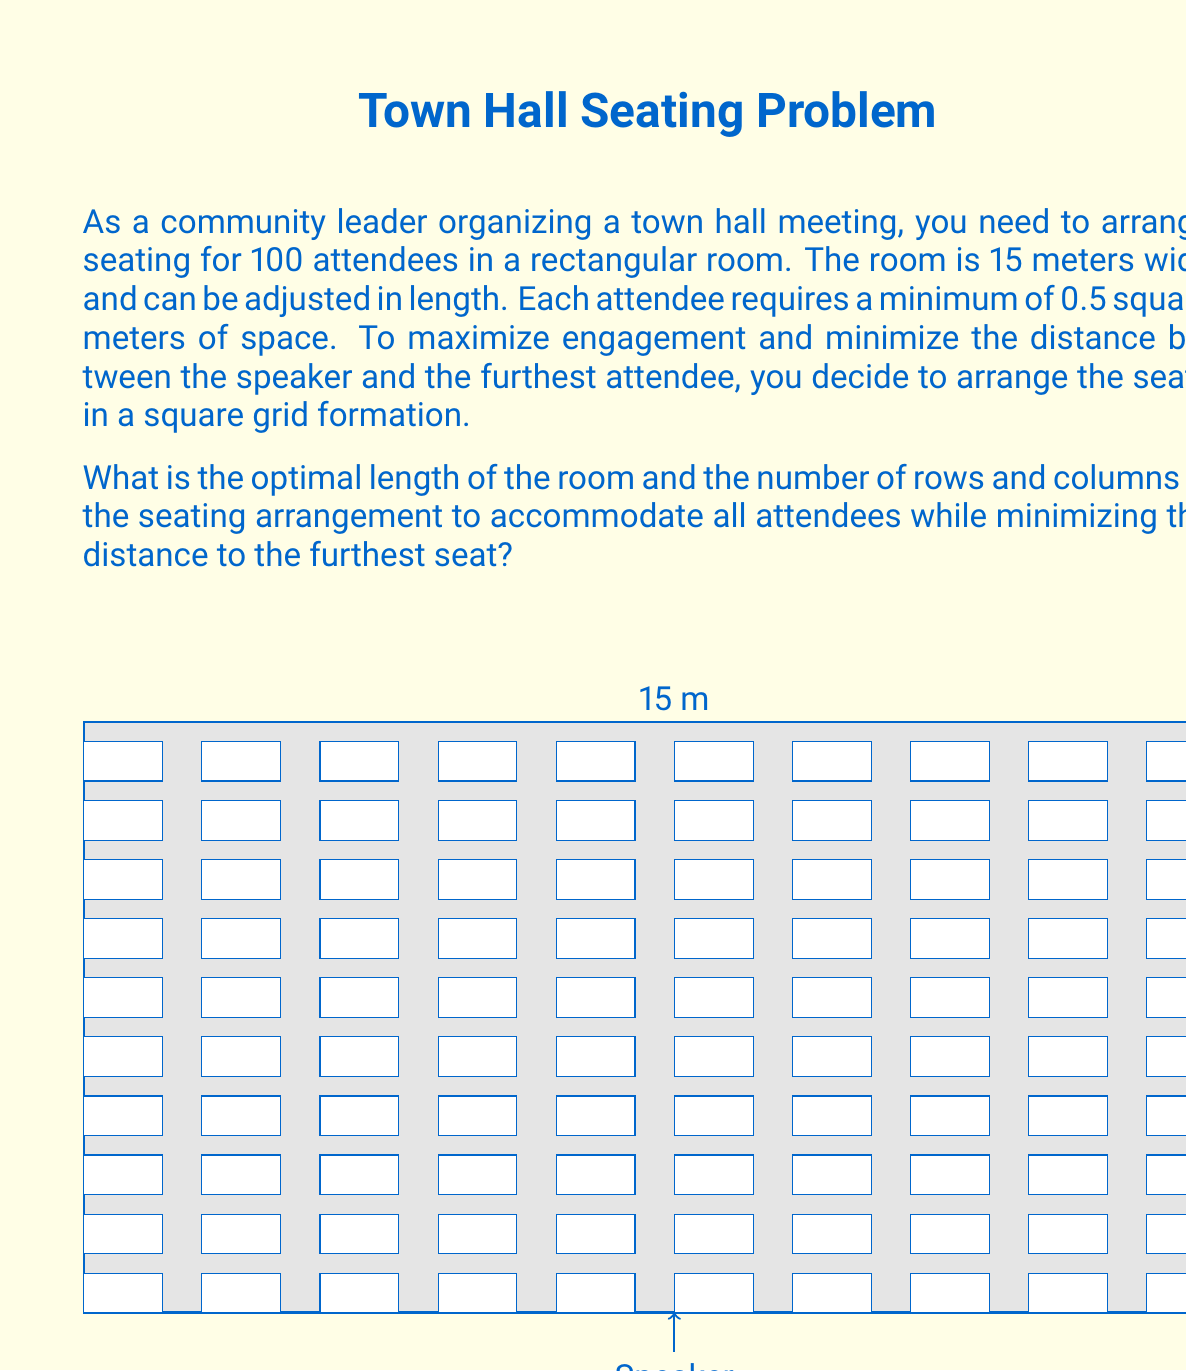Help me with this question. Let's approach this step-by-step:

1) First, we need to determine the number of rows and columns that will fit within the 15-meter width:

   $15 \text{ meters} \div \sqrt{0.5 \text{ m}^2} = 15 \div 0.7071 \approx 21.21$

   So, we can fit 21 seats across the width of the room.

2) To accommodate 100 attendees, we need:

   $100 \div 21 \approx 4.76$ rows

   Rounding up, we need 5 rows.

3) The actual number of seats in this arrangement will be:

   $21 \times 5 = 105$ seats

4) Now, let's calculate the length of the room:

   $5 \text{ rows} \times \sqrt{0.5 \text{ m}^2} = 5 \times 0.7071 = 3.5355 \text{ meters}$

5) To optimize engagement, we want to minimize the distance to the furthest seat. In a rectangular arrangement, this is achieved when the room is as close to square as possible. Our current arrangement is much wider than it is long, so we should consider a more square arrangement.

6) The optimal square arrangement would be:

   $\sqrt{100} = 10$ rows and columns

7) In this case, the width needed would be:

   $10 \times \sqrt{0.5 \text{ m}^2} = 10 \times 0.7071 = 7.071 \text{ meters}$

   Which fits within our 15-meter width constraint.

8) The length of the room in this arrangement would also be 7.071 meters.

This square arrangement minimizes the distance to the furthest seat while accommodating all attendees within the constraints.
Answer: 7.071 meters long, 10 rows, 10 columns 